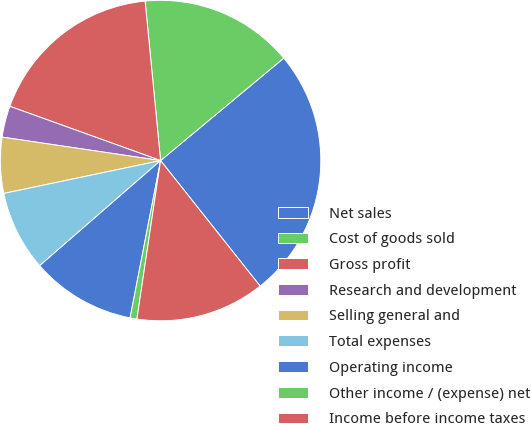Convert chart to OTSL. <chart><loc_0><loc_0><loc_500><loc_500><pie_chart><fcel>Net sales<fcel>Cost of goods sold<fcel>Gross profit<fcel>Research and development<fcel>Selling general and<fcel>Total expenses<fcel>Operating income<fcel>Other income / (expense) net<fcel>Income before income taxes<nl><fcel>25.37%<fcel>15.5%<fcel>17.96%<fcel>3.16%<fcel>5.63%<fcel>8.1%<fcel>10.56%<fcel>0.69%<fcel>13.03%<nl></chart> 